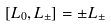<formula> <loc_0><loc_0><loc_500><loc_500>[ L _ { 0 } , L _ { \pm } ] = \pm L _ { \pm }</formula> 